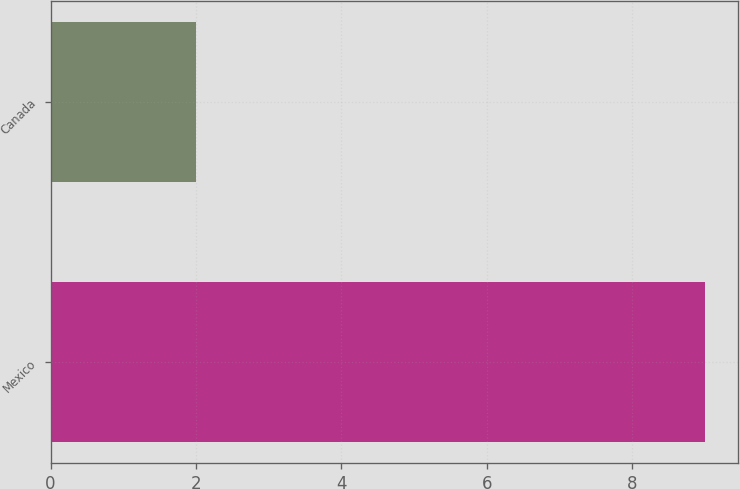<chart> <loc_0><loc_0><loc_500><loc_500><bar_chart><fcel>Mexico<fcel>Canada<nl><fcel>9<fcel>2<nl></chart> 